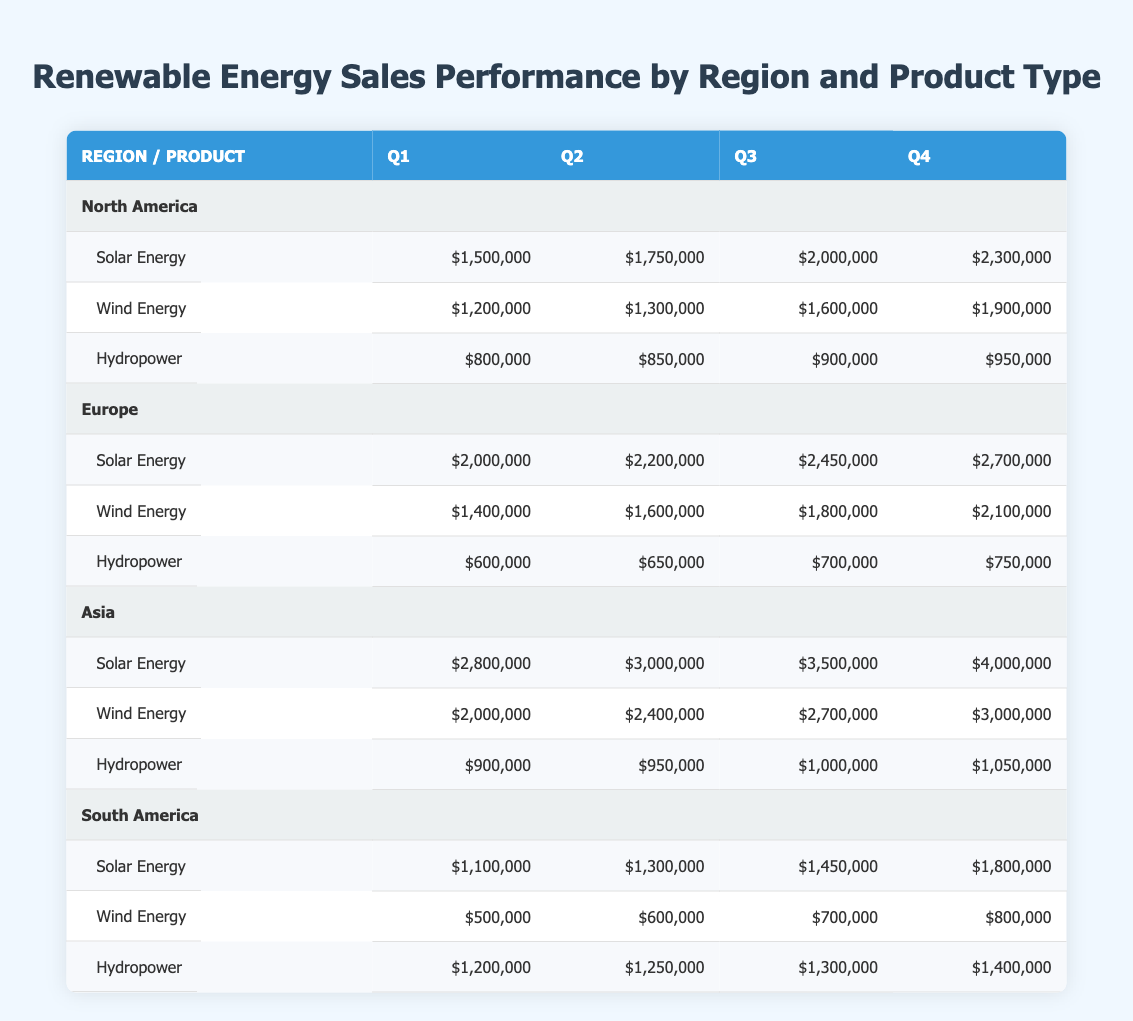What is the total sales for Wind Energy in Asia for all quarters? To find the total sales for Wind Energy in Asia, we add the sales figures from all four quarters: Q1 = 2,000,000 + Q2 = 2,400,000 + Q3 = 2,700,000 + Q4 = 3,000,000. This calculation results in a total of 2,000,000 + 2,400,000 + 2,700,000 + 3,000,000 = 10,100,000.
Answer: 10,100,000 Which product had the highest sales in Europe during Q4? In Europe, the sales figures during Q4 are as follows: Solar Energy = 2,700,000, Wind Energy = 2,100,000, and Hydropower = 750,000. The highest value is Solar Energy with 2,700,000.
Answer: Solar Energy Is the total sales of Hydropower in North America greater than the total sales of Wind Energy in South America? First, we calculate the total sales of Hydropower in North America: Q1 = 800,000 + Q2 = 850,000 + Q3 = 900,000 + Q4 = 950,000, which totals to 3,500,000. Next, we calculate Wind Energy's sales in South America: Q1 = 500,000 + Q2 = 600,000 + Q3 = 700,000 + Q4 = 800,000, totaling 2,600,000. Since 3,500,000 is greater than 2,600,000, the statement is true.
Answer: Yes What was the percentage increase in Solar Energy sales from Q1 to Q4 in South America? To calculate the percentage increase, we find the increase in sales: Q4 sales = 1,800,000 and Q1 sales = 1,100,000, so the increase is 1,800,000 - 1,100,000 = 700,000. Then, the percentage increase is calculated as (700,000 / 1,100,000) × 100 = 63.64%.
Answer: 63.64% Which region had the lowest sales for Hydropower in Q2? Looking at the sales figures for Q2 Hydropower: North America = 850,000, Europe = 650,000, Asia = 950,000, and South America = 1,250,000. The lowest figure is Europe with 650,000.
Answer: Europe 